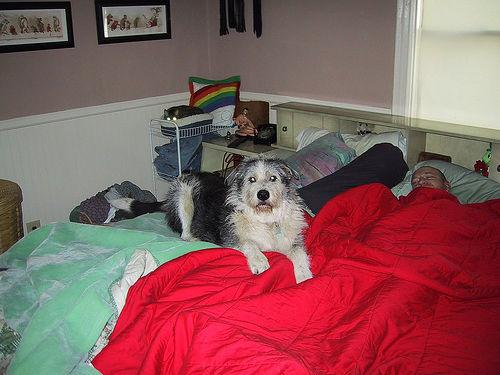Describe the art and decoration items visible in the image. There are framed paintings on the wall, two hanging pillows, and a picture on the wall, showcasing various colors and designs. Briefly narrate the central focus of the image. A cozy bedroom scene displays a man resting in bed with his dog and cat, surrounded by colorful pillows, artwork, and other household items. Identify the two animals on the bed, and suggest a possible relationship between them and the sleeping man. A dog and a cat are relaxing on the bed, perhaps being the man's beloved pets, sharing a quiet moment with their owner. Identify the main pieces of furniture and decorative elements in the image. A bed with a headboard, nightstand, wire basket, wooden clothing hamper, window with shade, and framed paintings on the wall. What are the items that can be found on the nightstand? A black telephone is positioned on the nightstand. Provide a brief overview of the main objects and actions in the image. A man is sleeping with a red blanket, a dog and cat are lying on the bed, there are multicolored pillows and a telephone on the nightstand, and multiple framed paintings on the wall. Describe the color theme and patterns observed in the items on the bed. The bed displays a vibrant mix of red, green, black, and multicolored pillows, along with a red blanket and a light green blanket creating a lively atmosphere. Use sensory language to describe the primary elements in the image. A serene bedroom, filled with the warm hues of a sleeping man under a red blanket, a cuddly dog, and a resting cat, accompanied by the soft textures of multicolored pillows and a green fuzzy blanket. What are the animals present in the image and their positions with respect to the man? A white and black dog is lying on the bed beside the sleeping man and a cat is lying on a wire basket in the room. Give a succinct description of the scene, highlighting the cohabitation of the man and animals in the picture. A harmonious picture of a man, a dog, and a cat, all taking a peaceful siesta in the comfort of a cozy bedroom filled with colorful cushions and appealing decor. 